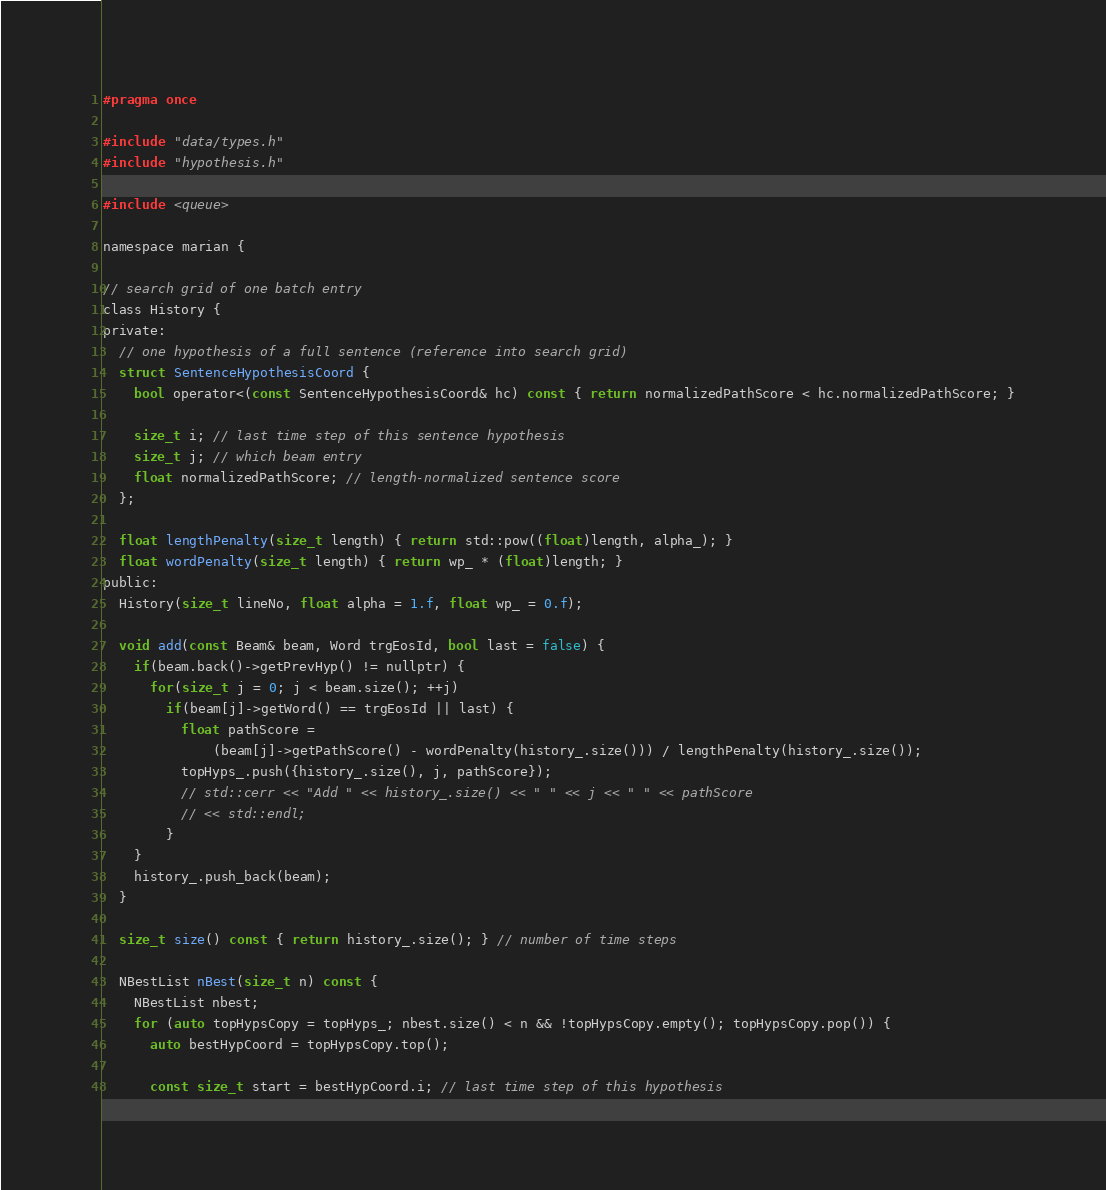Convert code to text. <code><loc_0><loc_0><loc_500><loc_500><_C_>#pragma once

#include "data/types.h"
#include "hypothesis.h"

#include <queue>

namespace marian {

// search grid of one batch entry
class History {
private:
  // one hypothesis of a full sentence (reference into search grid)
  struct SentenceHypothesisCoord {
    bool operator<(const SentenceHypothesisCoord& hc) const { return normalizedPathScore < hc.normalizedPathScore; }

    size_t i; // last time step of this sentence hypothesis
    size_t j; // which beam entry
    float normalizedPathScore; // length-normalized sentence score
  };

  float lengthPenalty(size_t length) { return std::pow((float)length, alpha_); }
  float wordPenalty(size_t length) { return wp_ * (float)length; }
public:
  History(size_t lineNo, float alpha = 1.f, float wp_ = 0.f);

  void add(const Beam& beam, Word trgEosId, bool last = false) {
    if(beam.back()->getPrevHyp() != nullptr) {
      for(size_t j = 0; j < beam.size(); ++j)
        if(beam[j]->getWord() == trgEosId || last) {
          float pathScore =
              (beam[j]->getPathScore() - wordPenalty(history_.size())) / lengthPenalty(history_.size());
          topHyps_.push({history_.size(), j, pathScore});
          // std::cerr << "Add " << history_.size() << " " << j << " " << pathScore
          // << std::endl;
        }
    }
    history_.push_back(beam);
  }

  size_t size() const { return history_.size(); } // number of time steps

  NBestList nBest(size_t n) const {
    NBestList nbest;
    for (auto topHypsCopy = topHyps_; nbest.size() < n && !topHypsCopy.empty(); topHypsCopy.pop()) {
      auto bestHypCoord = topHypsCopy.top();

      const size_t start = bestHypCoord.i; // last time step of this hypothesis</code> 